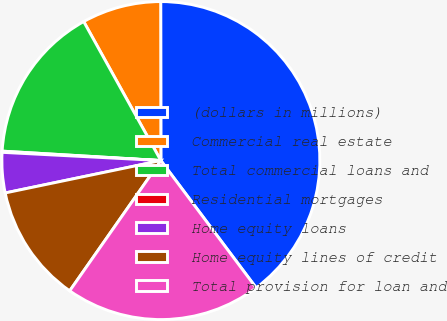Convert chart to OTSL. <chart><loc_0><loc_0><loc_500><loc_500><pie_chart><fcel>(dollars in millions)<fcel>Commercial real estate<fcel>Total commercial loans and<fcel>Residential mortgages<fcel>Home equity loans<fcel>Home equity lines of credit<fcel>Total provision for loan and<nl><fcel>39.79%<fcel>8.05%<fcel>15.99%<fcel>0.12%<fcel>4.09%<fcel>12.02%<fcel>19.95%<nl></chart> 